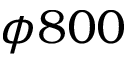Convert formula to latex. <formula><loc_0><loc_0><loc_500><loc_500>\phi 8 0 0</formula> 